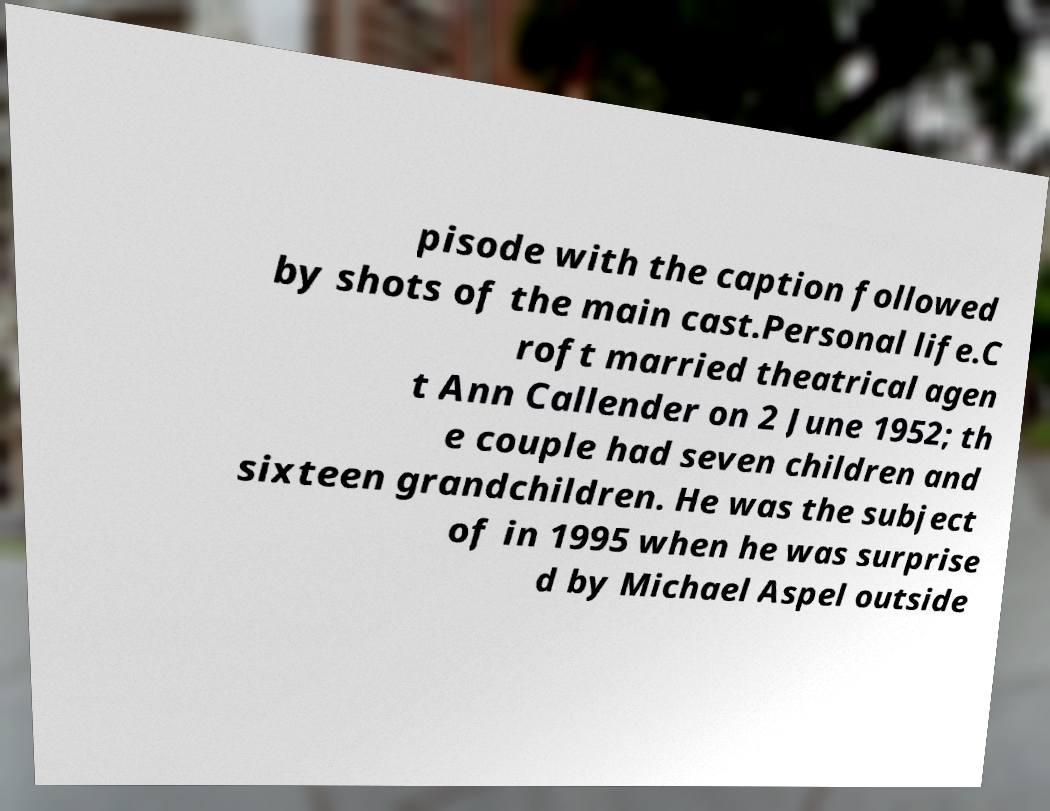Could you assist in decoding the text presented in this image and type it out clearly? pisode with the caption followed by shots of the main cast.Personal life.C roft married theatrical agen t Ann Callender on 2 June 1952; th e couple had seven children and sixteen grandchildren. He was the subject of in 1995 when he was surprise d by Michael Aspel outside 